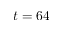Convert formula to latex. <formula><loc_0><loc_0><loc_500><loc_500>t = 6 4</formula> 